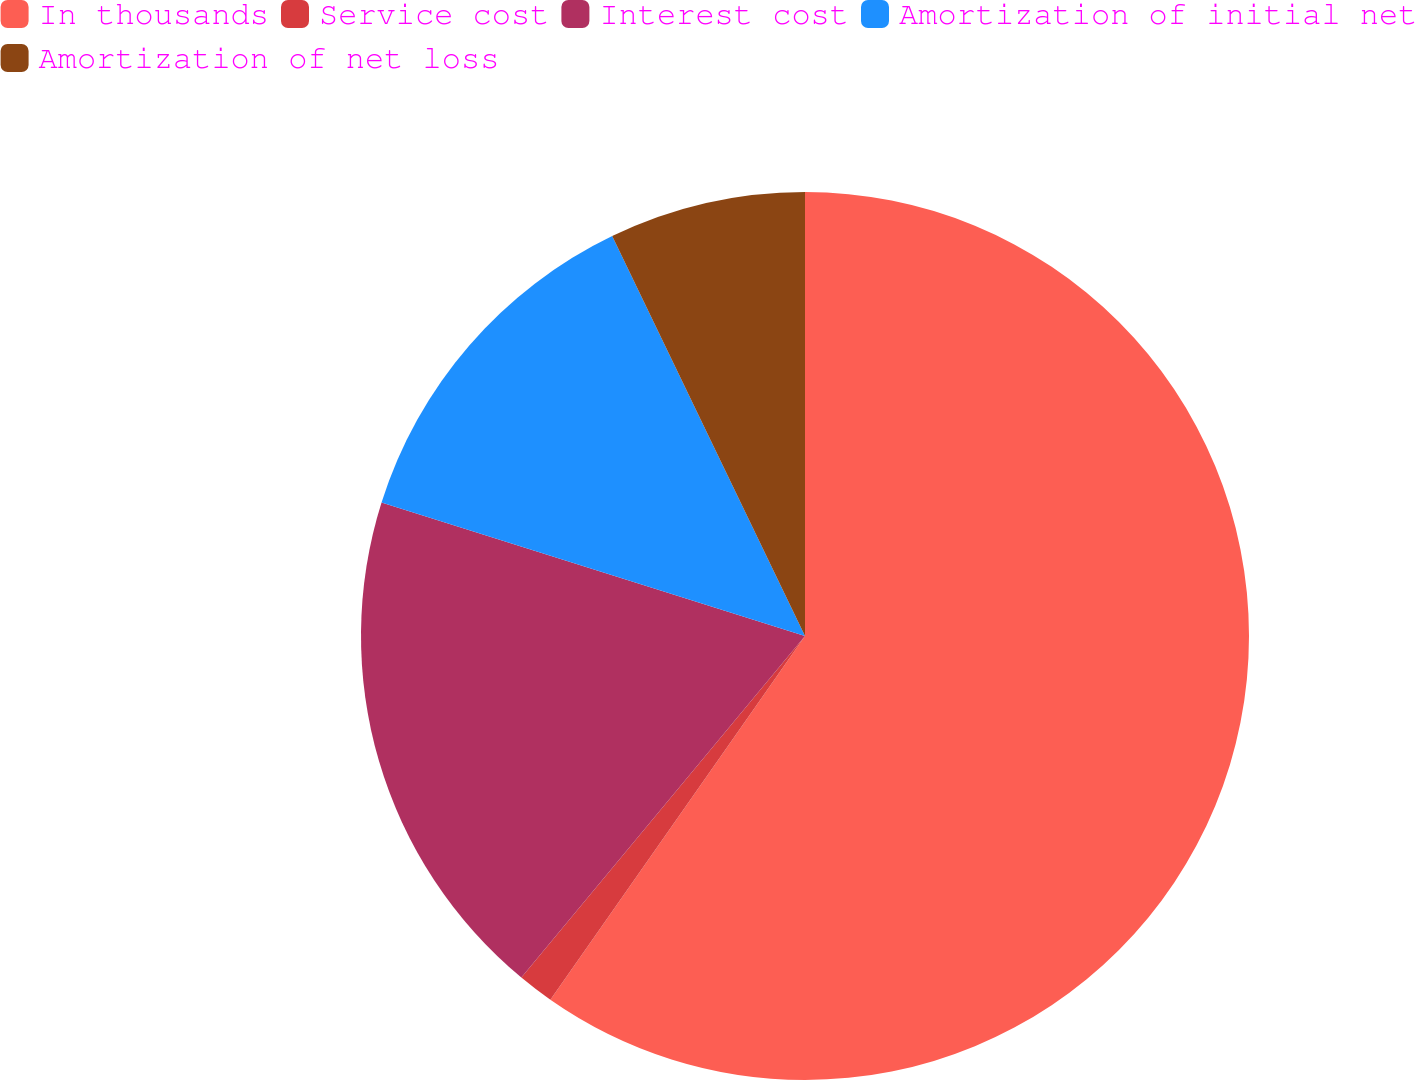Convert chart. <chart><loc_0><loc_0><loc_500><loc_500><pie_chart><fcel>In thousands<fcel>Service cost<fcel>Interest cost<fcel>Amortization of initial net<fcel>Amortization of net loss<nl><fcel>59.72%<fcel>1.31%<fcel>18.83%<fcel>12.99%<fcel>7.15%<nl></chart> 